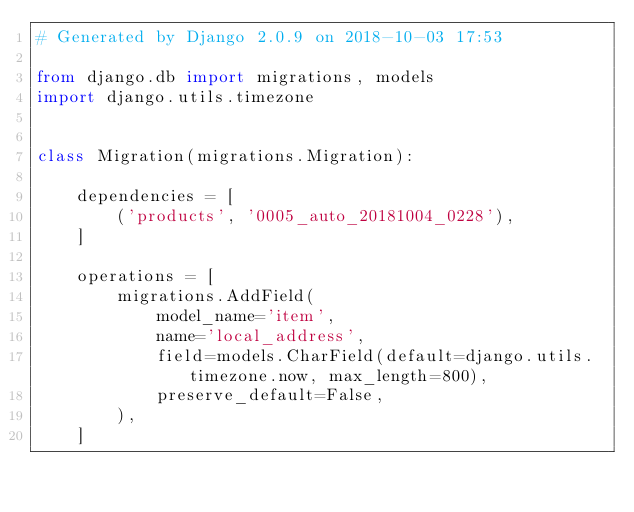<code> <loc_0><loc_0><loc_500><loc_500><_Python_># Generated by Django 2.0.9 on 2018-10-03 17:53

from django.db import migrations, models
import django.utils.timezone


class Migration(migrations.Migration):

    dependencies = [
        ('products', '0005_auto_20181004_0228'),
    ]

    operations = [
        migrations.AddField(
            model_name='item',
            name='local_address',
            field=models.CharField(default=django.utils.timezone.now, max_length=800),
            preserve_default=False,
        ),
    ]
</code> 